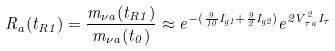Convert formula to latex. <formula><loc_0><loc_0><loc_500><loc_500>R _ { a } ( t _ { R 1 } ) = \frac { m _ { \nu a } ( t _ { R 1 } ) } { m _ { \nu a } ( t _ { 0 } ) } \approx e ^ { - ( \frac { 9 } { 1 0 } I _ { g 1 } + \frac { 9 } { 2 } I _ { g 2 } ) } e ^ { 2 V _ { \tau a } ^ { 2 } I _ { \tau } }</formula> 